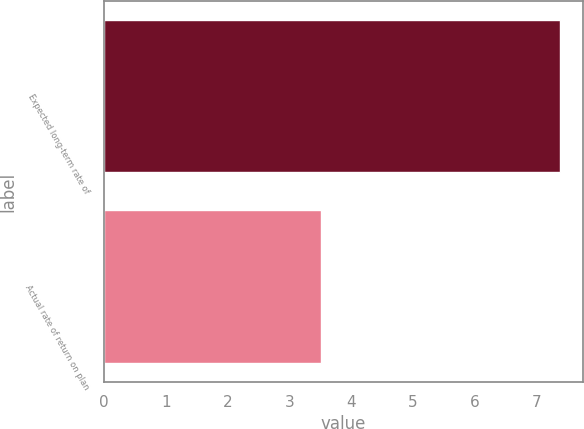Convert chart. <chart><loc_0><loc_0><loc_500><loc_500><bar_chart><fcel>Expected long-term rate of<fcel>Actual rate of return on plan<nl><fcel>7.38<fcel>3.51<nl></chart> 